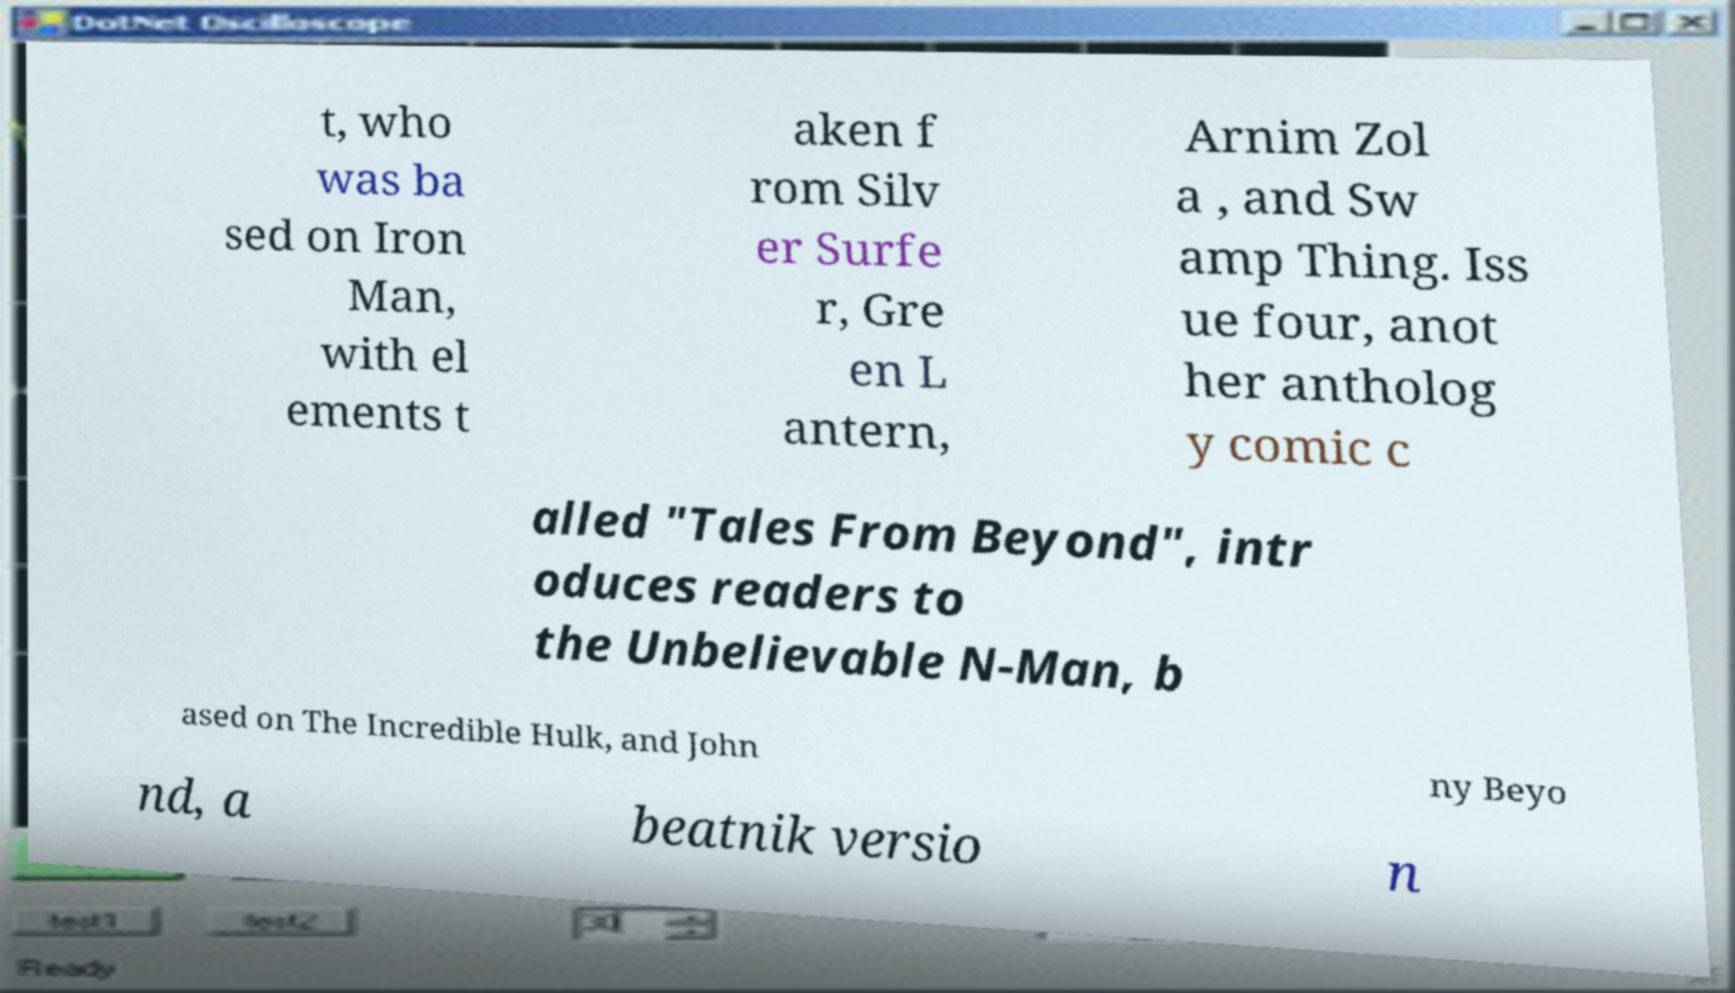Please identify and transcribe the text found in this image. t, who was ba sed on Iron Man, with el ements t aken f rom Silv er Surfe r, Gre en L antern, Arnim Zol a , and Sw amp Thing. Iss ue four, anot her antholog y comic c alled "Tales From Beyond", intr oduces readers to the Unbelievable N-Man, b ased on The Incredible Hulk, and John ny Beyo nd, a beatnik versio n 